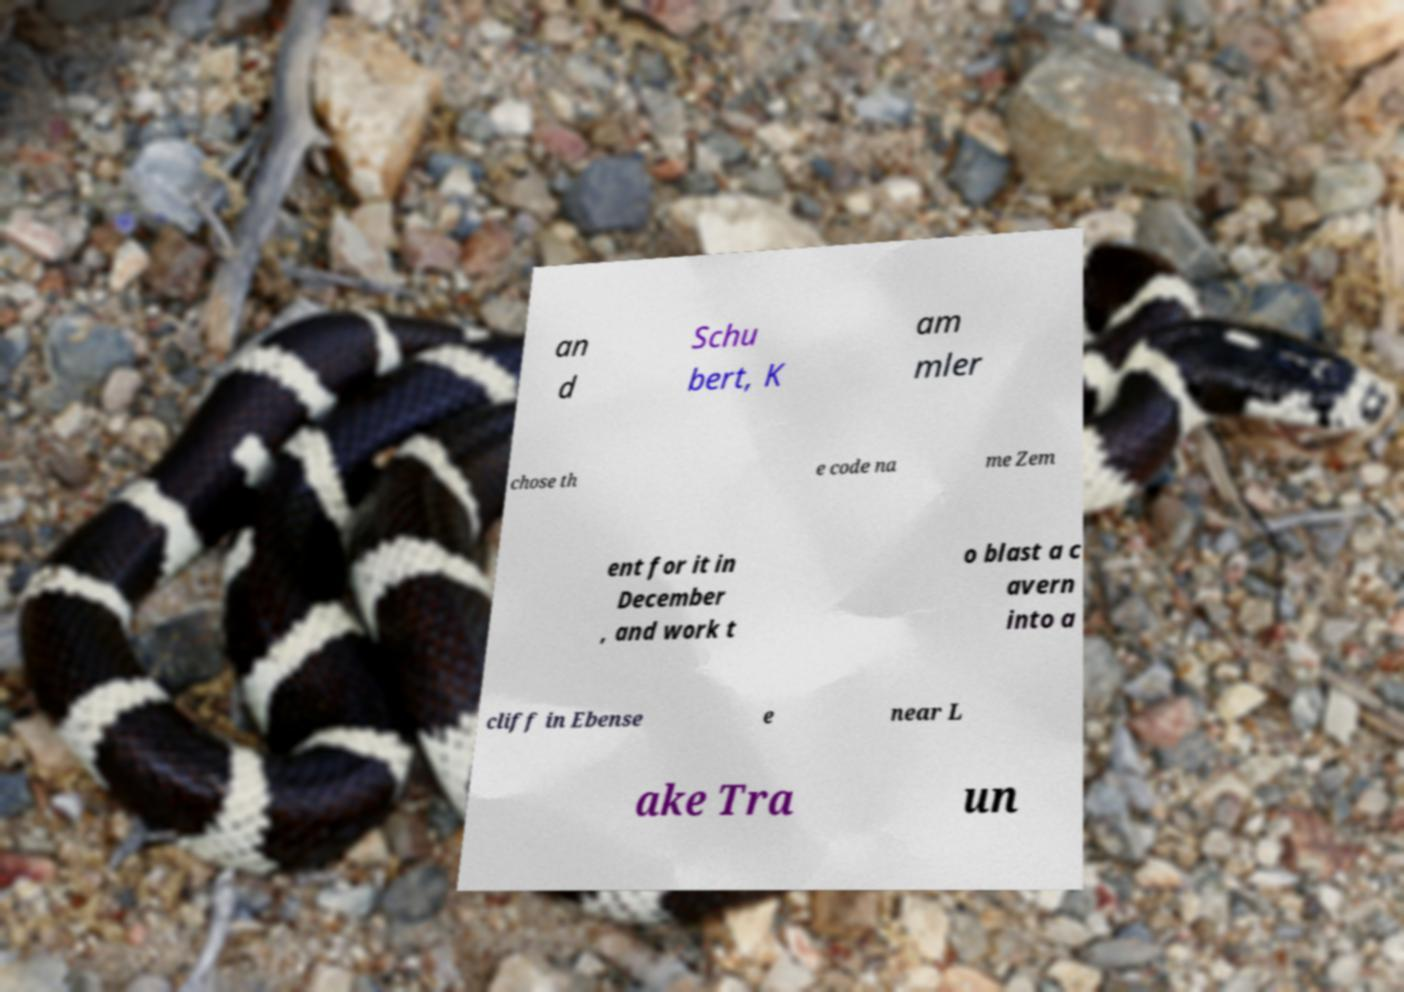Could you extract and type out the text from this image? an d Schu bert, K am mler chose th e code na me Zem ent for it in December , and work t o blast a c avern into a cliff in Ebense e near L ake Tra un 